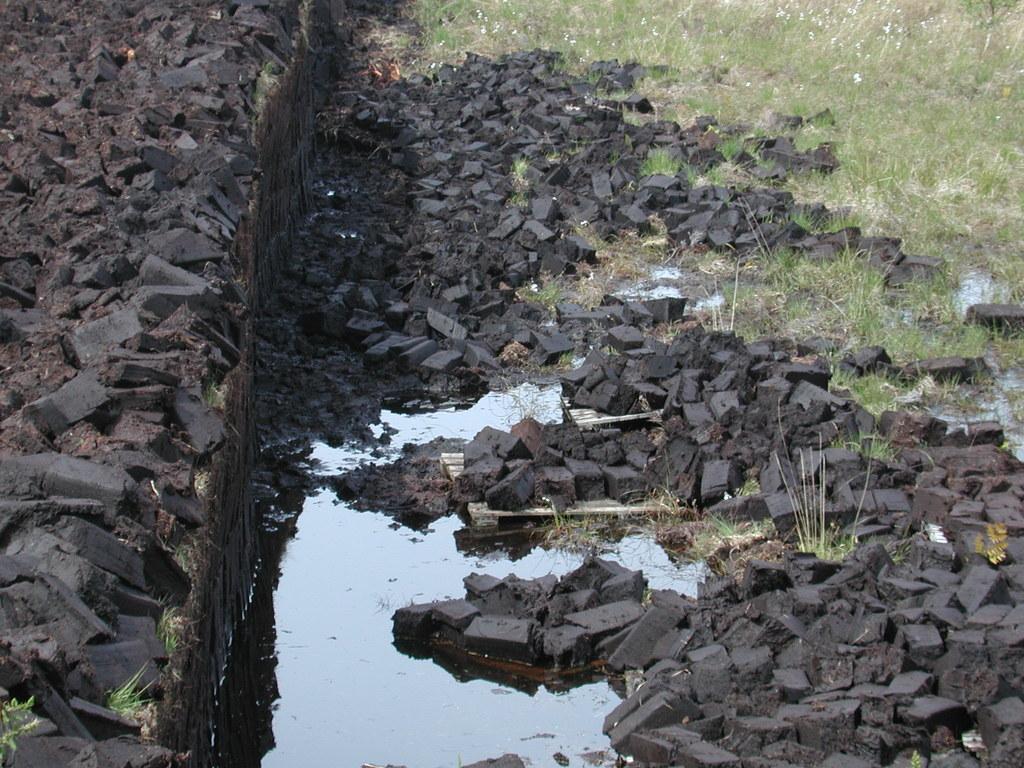Can you describe this image briefly? In the image there are black stones on the ground. And also there is water and grass on the ground. 